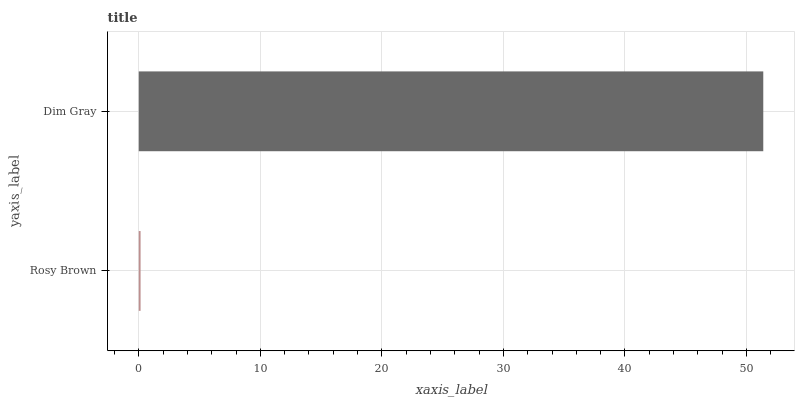Is Rosy Brown the minimum?
Answer yes or no. Yes. Is Dim Gray the maximum?
Answer yes or no. Yes. Is Dim Gray the minimum?
Answer yes or no. No. Is Dim Gray greater than Rosy Brown?
Answer yes or no. Yes. Is Rosy Brown less than Dim Gray?
Answer yes or no. Yes. Is Rosy Brown greater than Dim Gray?
Answer yes or no. No. Is Dim Gray less than Rosy Brown?
Answer yes or no. No. Is Dim Gray the high median?
Answer yes or no. Yes. Is Rosy Brown the low median?
Answer yes or no. Yes. Is Rosy Brown the high median?
Answer yes or no. No. Is Dim Gray the low median?
Answer yes or no. No. 